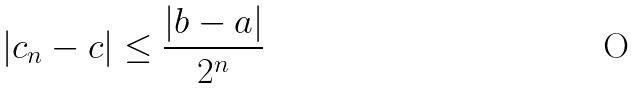Convert formula to latex. <formula><loc_0><loc_0><loc_500><loc_500>| c _ { n } - c | \leq \frac { | b - a | } { 2 ^ { n } }</formula> 